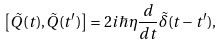Convert formula to latex. <formula><loc_0><loc_0><loc_500><loc_500>\left [ \tilde { Q } ( t ) , \tilde { Q } ( t ^ { \prime } ) \right ] = 2 i \hbar { \eta } \frac { d } { d t } \tilde { \delta } ( t - t ^ { \prime } ) ,</formula> 